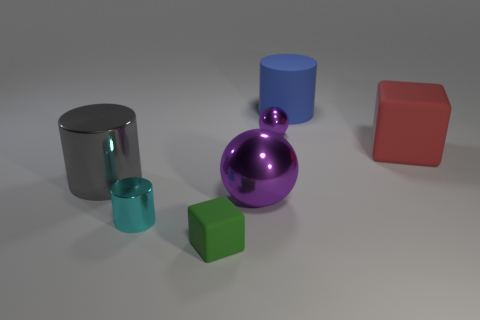Add 1 big gray things. How many objects exist? 8 Subtract all blue cylinders. How many cylinders are left? 2 Subtract all cylinders. How many objects are left? 4 Add 3 small purple metal objects. How many small purple metal objects exist? 4 Subtract all green cubes. How many cubes are left? 1 Subtract 0 yellow cubes. How many objects are left? 7 Subtract 2 cylinders. How many cylinders are left? 1 Subtract all blue cylinders. Subtract all cyan balls. How many cylinders are left? 2 Subtract all gray blocks. How many blue cylinders are left? 1 Subtract all green cubes. Subtract all cyan cylinders. How many objects are left? 5 